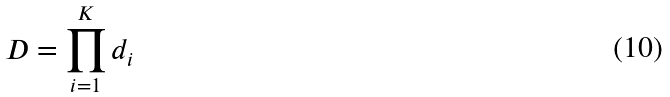Convert formula to latex. <formula><loc_0><loc_0><loc_500><loc_500>D = \prod _ { i = 1 } ^ { K } d _ { i }</formula> 